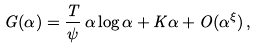<formula> <loc_0><loc_0><loc_500><loc_500>G ( \alpha ) = \frac { T } { \psi } \, \alpha \log \alpha + K \alpha + O ( \alpha ^ { \xi } ) \, ,</formula> 